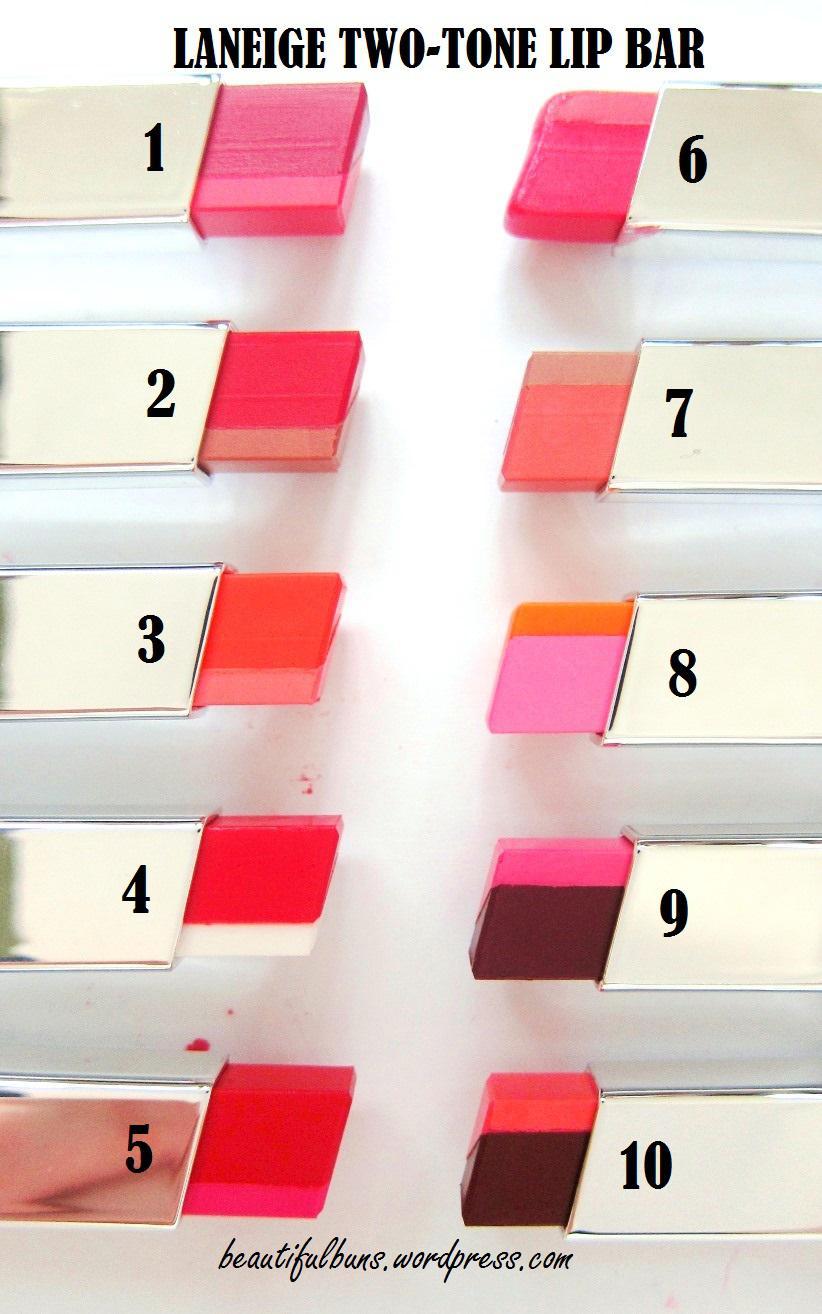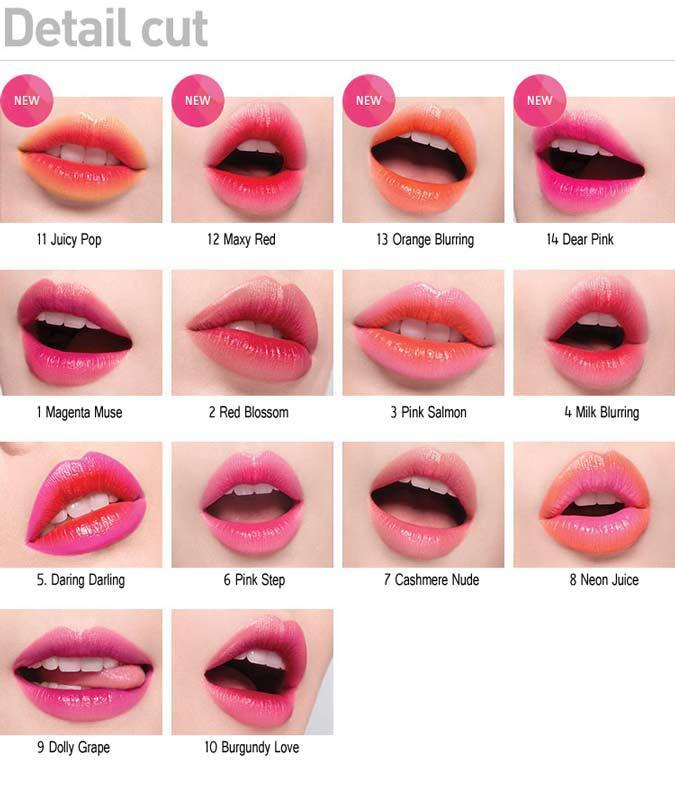The first image is the image on the left, the second image is the image on the right. Analyze the images presented: Is the assertion "An image shows a collage of at least ten painted pairs of lips." valid? Answer yes or no. Yes. The first image is the image on the left, the second image is the image on the right. Evaluate the accuracy of this statement regarding the images: "One image shows 5 or more tubes of lipstick, and the other shows how the colors look when applied to the lips.". Is it true? Answer yes or no. Yes. 